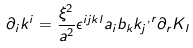Convert formula to latex. <formula><loc_0><loc_0><loc_500><loc_500>{ \partial } _ { i } k ^ { i } = \frac { { \xi } ^ { 2 } } { a ^ { 2 } } { \epsilon } ^ { i j k l } a _ { i } b _ { k } { k _ { j } } ^ { , r } { \partial } _ { r } K _ { l }</formula> 